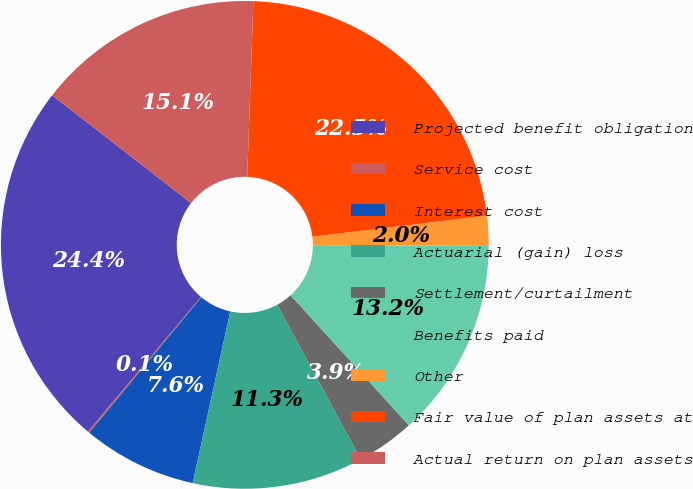Convert chart. <chart><loc_0><loc_0><loc_500><loc_500><pie_chart><fcel>Projected benefit obligation<fcel>Service cost<fcel>Interest cost<fcel>Actuarial (gain) loss<fcel>Settlement/curtailment<fcel>Benefits paid<fcel>Other<fcel>Fair value of plan assets at<fcel>Actual return on plan assets<nl><fcel>24.39%<fcel>0.11%<fcel>7.58%<fcel>11.32%<fcel>3.85%<fcel>13.19%<fcel>1.98%<fcel>22.52%<fcel>15.05%<nl></chart> 